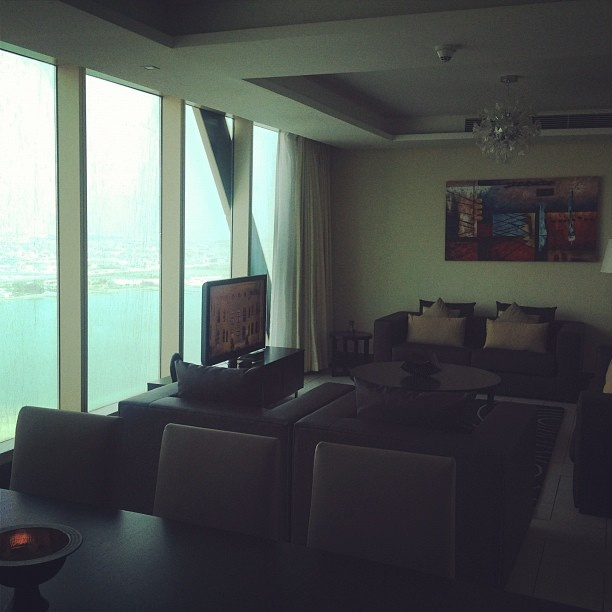Describe the objects in this image and their specific colors. I can see dining table in black and purple tones, couch in black and gray tones, chair in black and gray tones, couch in black and gray tones, and chair in black and gray tones in this image. 